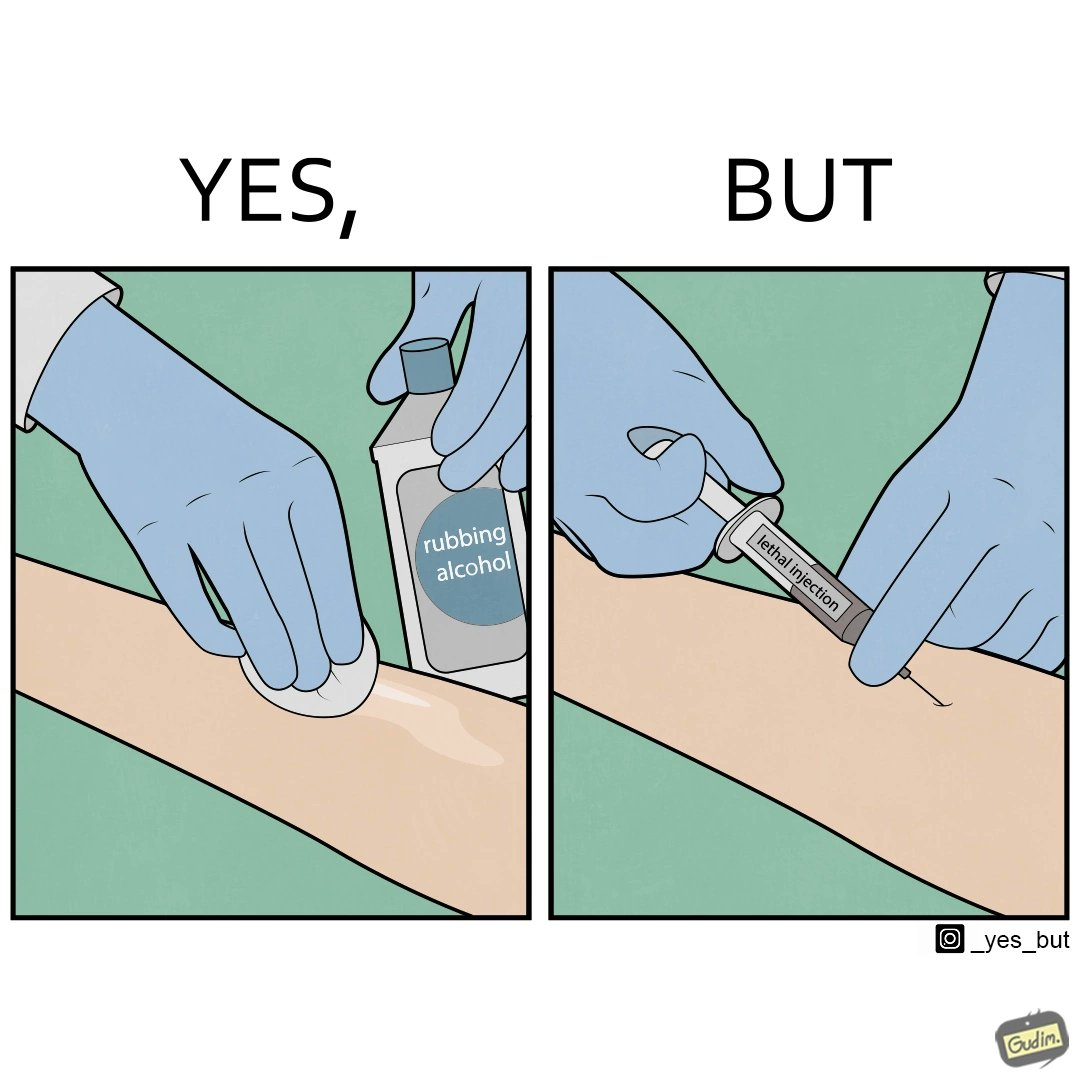Explain the humor or irony in this image. The image is ironical, as rubbing alcohol is used to clean a place on the arm for giving an injection, while the injection itself is 'lethal'. 